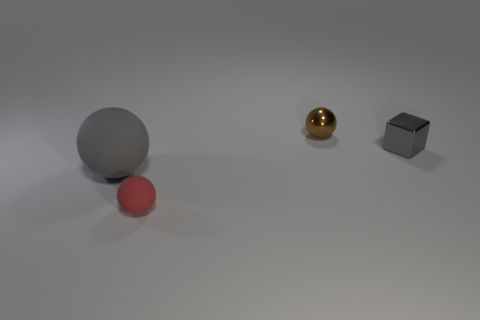What is the material of the large sphere that is the same color as the tiny block?
Keep it short and to the point. Rubber. How many other objects are there of the same color as the tiny cube?
Offer a very short reply. 1. There is a small shiny thing that is on the right side of the brown object; is its shape the same as the big rubber object?
Give a very brief answer. No. What color is the other sphere that is made of the same material as the tiny red ball?
Make the answer very short. Gray. There is a small sphere right of the small matte ball; what material is it?
Provide a short and direct response. Metal. There is a red thing; is its shape the same as the gray thing that is to the right of the brown metallic thing?
Provide a succinct answer. No. What material is the sphere that is both on the right side of the gray rubber thing and in front of the tiny gray metallic cube?
Your response must be concise. Rubber. The other metallic thing that is the same size as the gray shiny object is what color?
Make the answer very short. Brown. Do the large sphere and the tiny ball in front of the gray shiny thing have the same material?
Offer a terse response. Yes. How many other objects are the same size as the gray metal object?
Your answer should be compact. 2. 